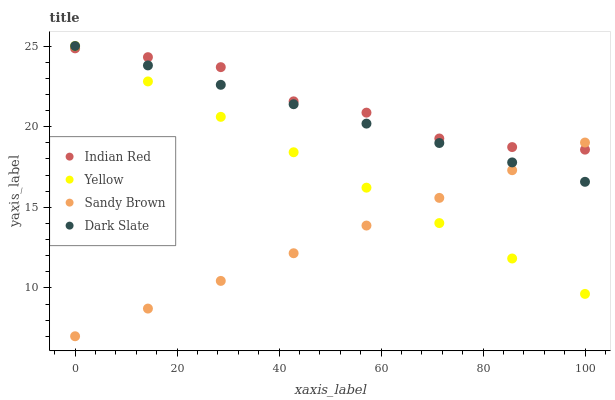Does Sandy Brown have the minimum area under the curve?
Answer yes or no. Yes. Does Indian Red have the maximum area under the curve?
Answer yes or no. Yes. Does Yellow have the minimum area under the curve?
Answer yes or no. No. Does Yellow have the maximum area under the curve?
Answer yes or no. No. Is Yellow the smoothest?
Answer yes or no. Yes. Is Indian Red the roughest?
Answer yes or no. Yes. Is Sandy Brown the smoothest?
Answer yes or no. No. Is Sandy Brown the roughest?
Answer yes or no. No. Does Sandy Brown have the lowest value?
Answer yes or no. Yes. Does Yellow have the lowest value?
Answer yes or no. No. Does Yellow have the highest value?
Answer yes or no. Yes. Does Sandy Brown have the highest value?
Answer yes or no. No. Does Yellow intersect Indian Red?
Answer yes or no. Yes. Is Yellow less than Indian Red?
Answer yes or no. No. Is Yellow greater than Indian Red?
Answer yes or no. No. 